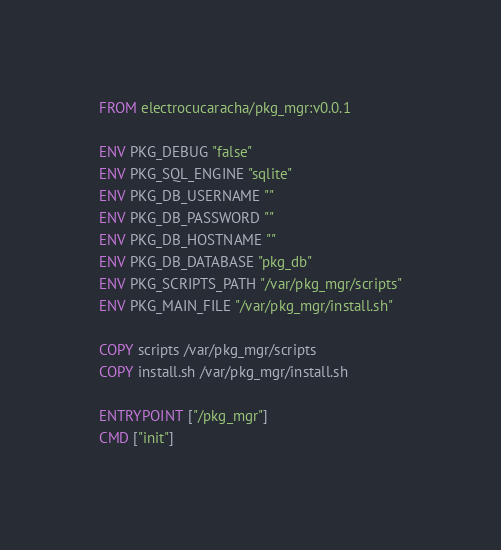Convert code to text. <code><loc_0><loc_0><loc_500><loc_500><_Dockerfile_>FROM electrocucaracha/pkg_mgr:v0.0.1

ENV PKG_DEBUG "false"
ENV PKG_SQL_ENGINE "sqlite"
ENV PKG_DB_USERNAME ""
ENV PKG_DB_PASSWORD ""
ENV PKG_DB_HOSTNAME ""
ENV PKG_DB_DATABASE "pkg_db"
ENV PKG_SCRIPTS_PATH "/var/pkg_mgr/scripts"
ENV PKG_MAIN_FILE "/var/pkg_mgr/install.sh"

COPY scripts /var/pkg_mgr/scripts
COPY install.sh /var/pkg_mgr/install.sh

ENTRYPOINT ["/pkg_mgr"]
CMD ["init"]
</code> 